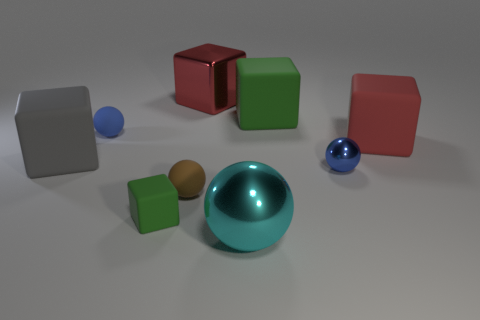What could be the purpose of arranging these objects in such a manner? This arrangement might be designed for a visual study or as an art piece. It brings out the interplay of geometric shapes, colors, and sizes, allowing observers to appreciate the contrast and harmony. Additionally, it could serve an educational purpose, perhaps in a tutorial about three-dimensional rendering and material properties. 